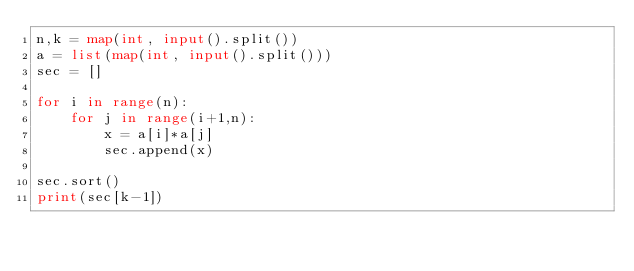<code> <loc_0><loc_0><loc_500><loc_500><_Python_>n,k = map(int, input().split())
a = list(map(int, input().split()))
sec = []

for i in range(n):
    for j in range(i+1,n):
        x = a[i]*a[j]
        sec.append(x)

sec.sort()
print(sec[k-1])
</code> 